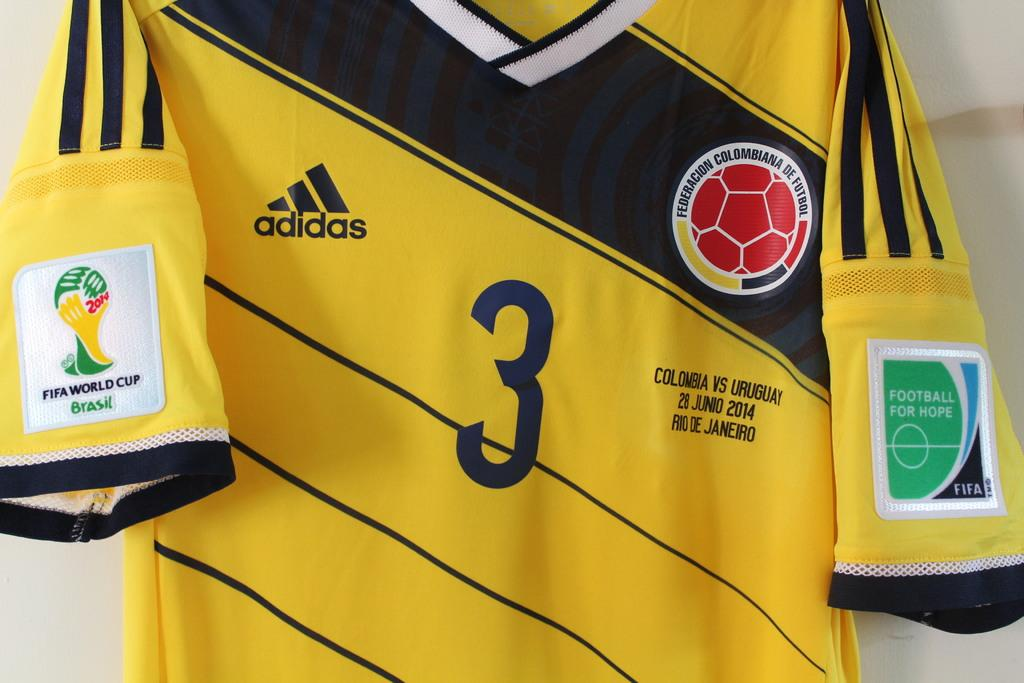<image>
Create a compact narrative representing the image presented. A yellow and black jersey with the number 3 on it is hanging up on against a white wall. 